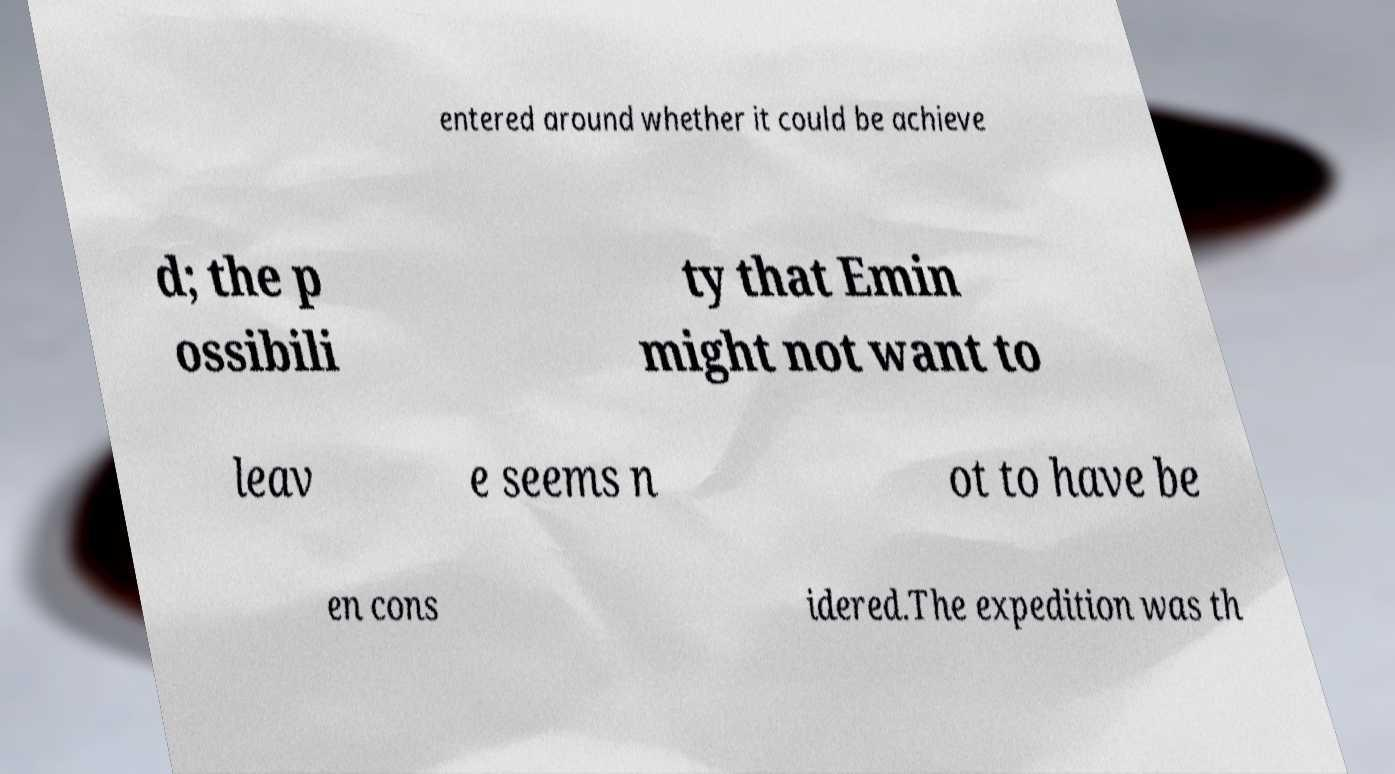There's text embedded in this image that I need extracted. Can you transcribe it verbatim? entered around whether it could be achieve d; the p ossibili ty that Emin might not want to leav e seems n ot to have be en cons idered.The expedition was th 